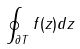Convert formula to latex. <formula><loc_0><loc_0><loc_500><loc_500>\oint _ { \partial T } f ( z ) d z</formula> 